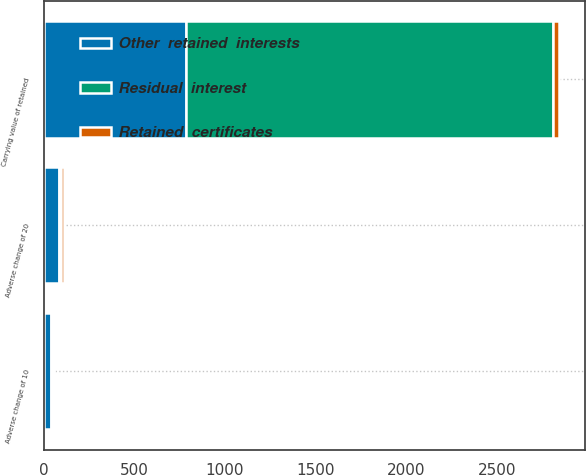<chart> <loc_0><loc_0><loc_500><loc_500><stacked_bar_chart><ecel><fcel>Carrying value of retained<fcel>Adverse change of 10<fcel>Adverse change of 20<nl><fcel>Other  retained  interests<fcel>786<fcel>42<fcel>83<nl><fcel>Retained  certificates<fcel>31<fcel>10<fcel>20<nl><fcel>Residual  interest<fcel>2024<fcel>6<fcel>12<nl></chart> 